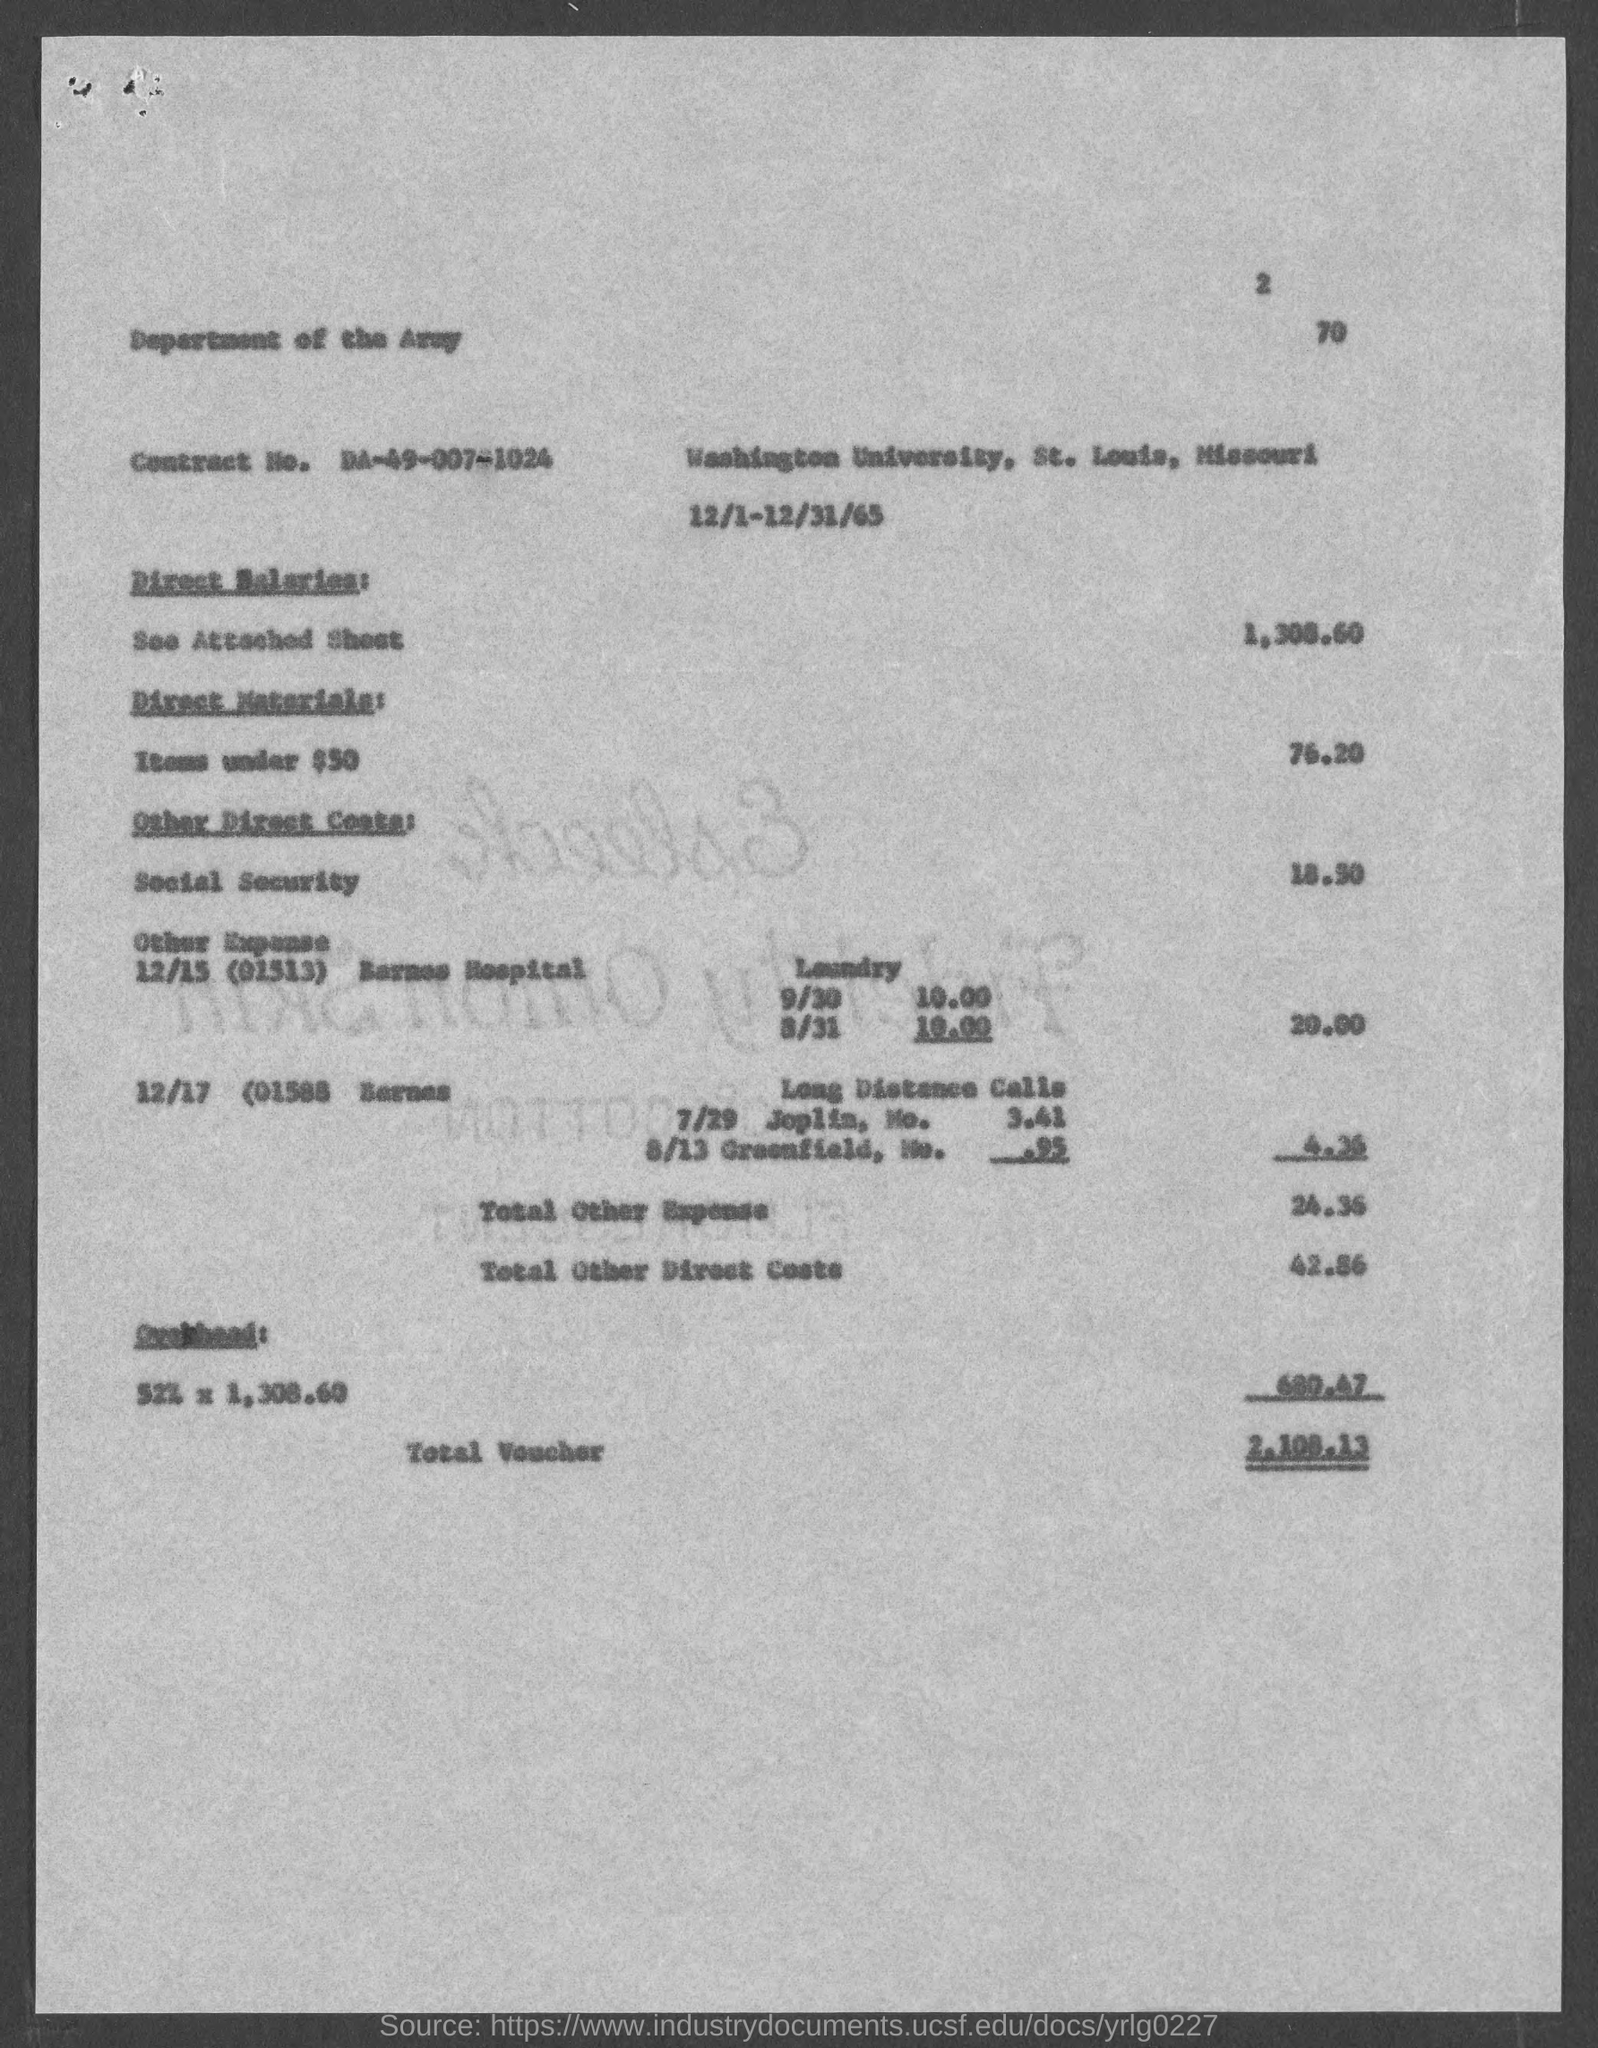What is the page number at top of the page?
Provide a short and direct response. 2. What is the contract no.?
Give a very brief answer. DA-49-007-1024. What is the total voucher amount ?
Give a very brief answer. $2,108.13. 